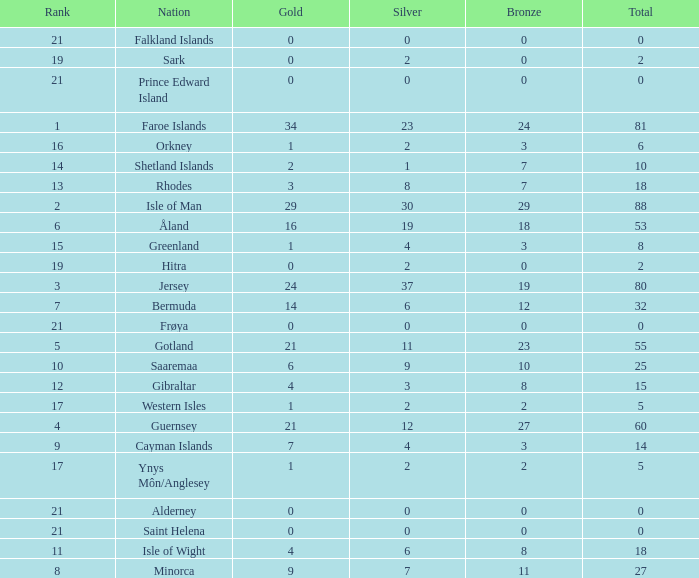How many Silver medals were won in total by all those with more than 3 bronze and exactly 16 gold? 19.0. 